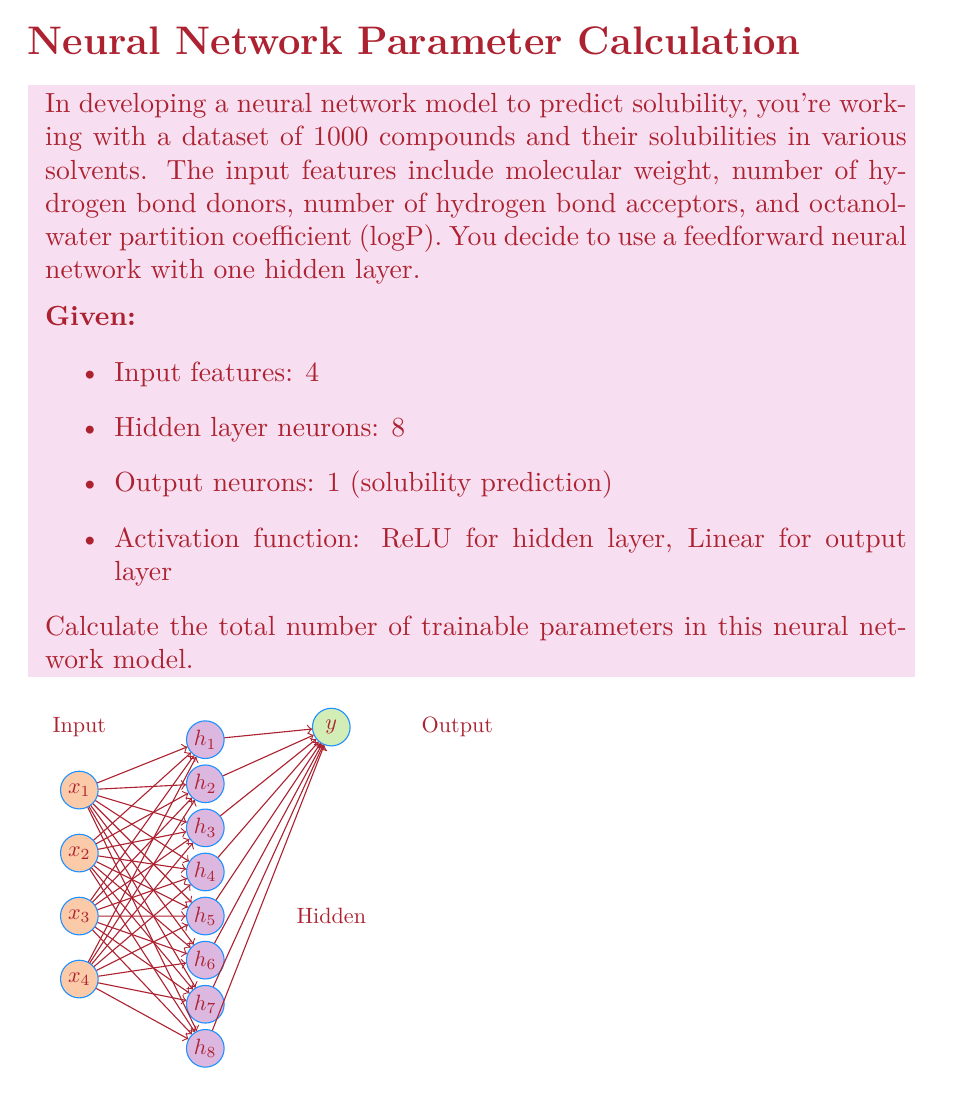Can you solve this math problem? Let's break down the calculation of trainable parameters step-by-step:

1) Connections between input and hidden layer:
   - Each input neuron connects to every hidden neuron
   - Number of connections = 4 (input features) × 8 (hidden neurons) = 32
   - Each connection has a weight, so there are 32 weights

2) Biases for hidden layer:
   - Each hidden neuron has a bias
   - Number of biases = 8

3) Connections between hidden and output layer:
   - Each hidden neuron connects to the output neuron
   - Number of connections = 8 (hidden neurons) × 1 (output neuron) = 8
   - Each connection has a weight, so there are 8 weights

4) Bias for output layer:
   - The output neuron has a bias
   - Number of biases = 1

5) Total number of trainable parameters:
   $$ \text{Total} = \text{Input-Hidden weights} + \text{Hidden biases} + \text{Hidden-Output weights} + \text{Output bias} $$
   $$ \text{Total} = 32 + 8 + 8 + 1 = 49 $$

Therefore, the total number of trainable parameters in this neural network model is 49.
Answer: 49 parameters 